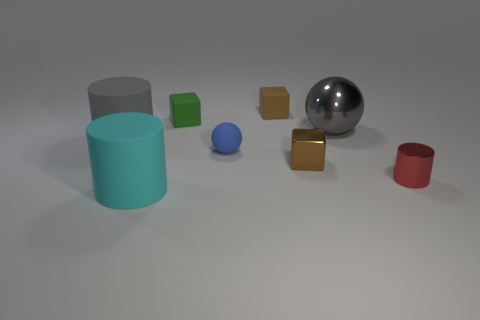Add 2 large red metal cylinders. How many objects exist? 10 Subtract all small metal cylinders. How many cylinders are left? 2 Subtract all balls. How many objects are left? 6 Subtract all green cylinders. How many brown blocks are left? 2 Subtract 2 blocks. How many blocks are left? 1 Subtract all brown blocks. Subtract all red cylinders. How many blocks are left? 1 Subtract all small blue shiny balls. Subtract all blue matte things. How many objects are left? 7 Add 7 small red objects. How many small red objects are left? 8 Add 7 cyan things. How many cyan things exist? 8 Subtract all green blocks. How many blocks are left? 2 